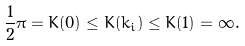Convert formula to latex. <formula><loc_0><loc_0><loc_500><loc_500>\frac { 1 } { 2 } \pi = K ( 0 ) \leq K ( k _ { i } ) \leq K ( 1 ) = \infty .</formula> 